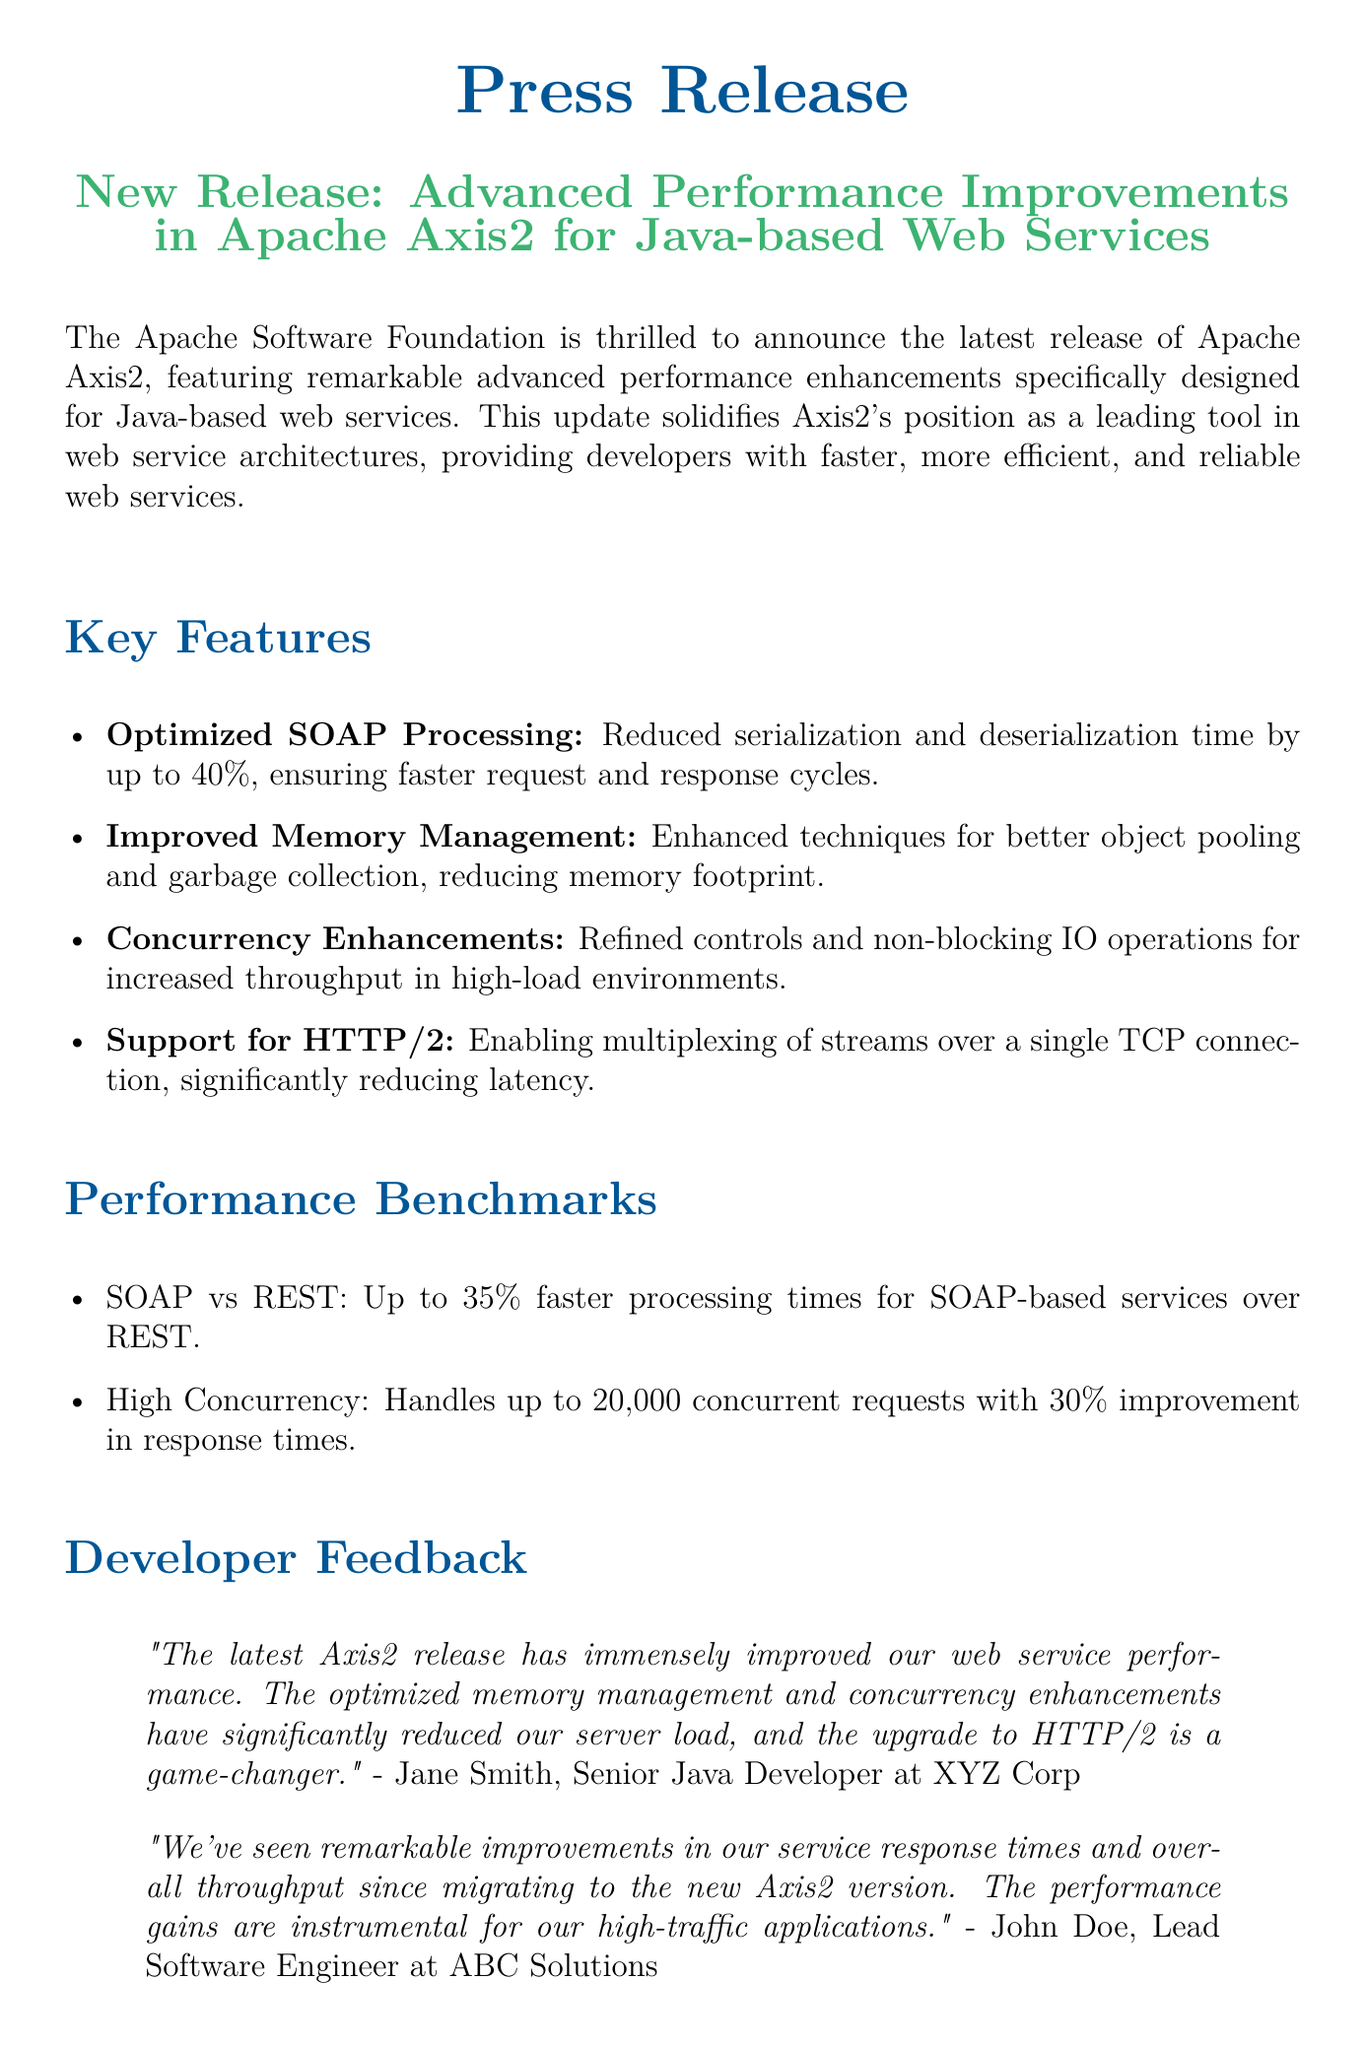What is the main focus of the new release? The main focus is on advanced performance improvements for Java-based web services in Apache Axis2.
Answer: Advanced performance improvements What percentage reduction in serialization and deserialization time is achieved? The document states that serialization and deserialization time is reduced by up to 40%.
Answer: 40% How many concurrent requests can the enhanced system handle? The document indicates that the system can handle up to 20,000 concurrent requests.
Answer: 20,000 Who provided feedback on the improvements in Axis2? Feedback was provided by Jane Smith and John Doe, both of whom are senior developers at respective companies.
Answer: Jane Smith and John Doe What is a significant new feature in the latest release concerning network protocol? The significant new feature is support for HTTP/2, which enables multiplexing of streams.
Answer: Support for HTTP/2 What type of memory management improvement is highlighted? The document highlights enhanced techniques for better object pooling and garbage collection.
Answer: Better object pooling and garbage collection What specific improvement percentage is reported for SOAP-based services' processing times over REST? The document reports up to 35% faster processing times for SOAP-based services compared to REST.
Answer: 35% What is the document's call to action for developers? Developers are encouraged to download the latest version of Apache Axis2 from the official website.
Answer: Download the latest version of Apache Axis2 